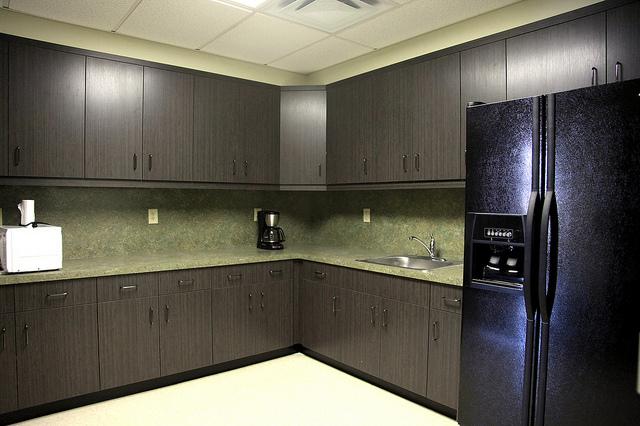Is this kitchen clean or dirty?
Keep it brief. Clean. What is dispensed if one of the levers on the front of the refrigerator is pushed?
Be succinct. Water. Are the lights on?
Quick response, please. Yes. 